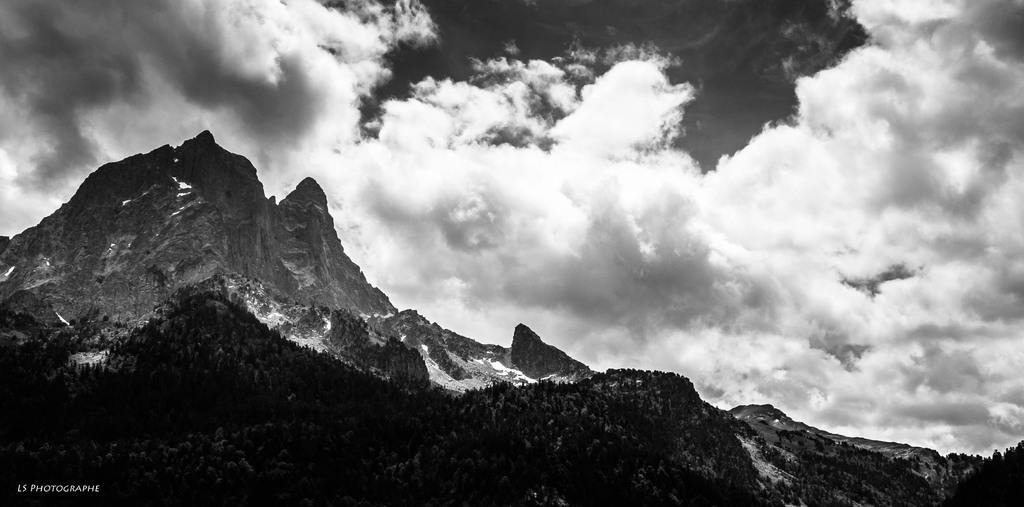How would you summarize this image in a sentence or two? In bottom left, there is a watermark. In the background, there are mountains and there are clouds in the sky. 